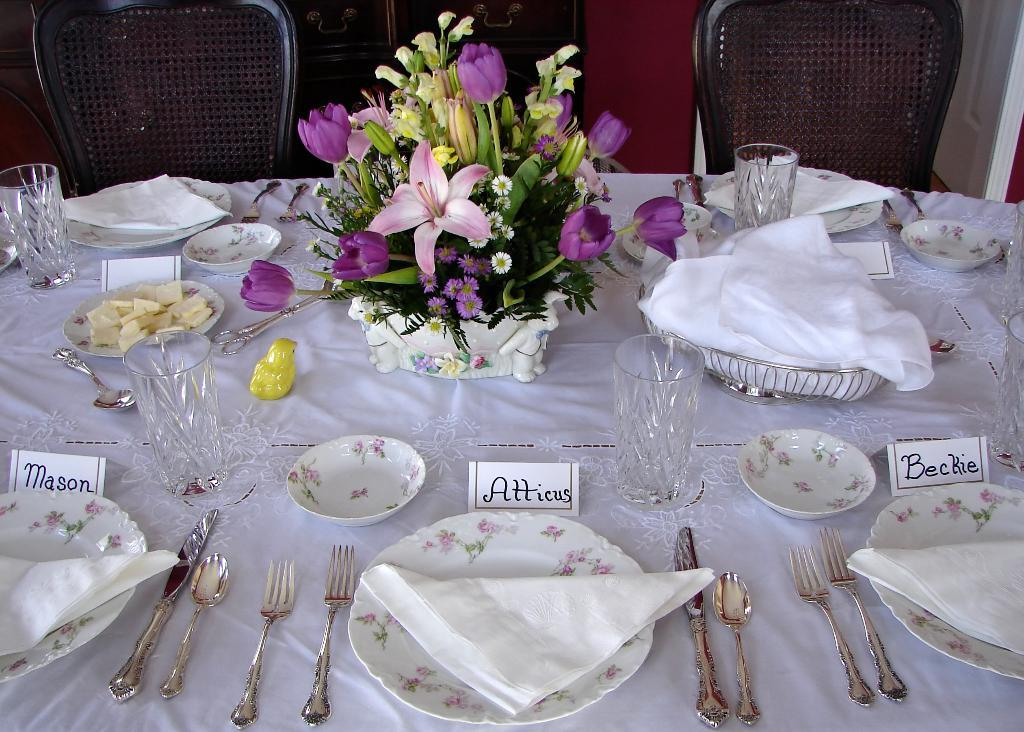What is covering the table in the image? There is a table with a white cloth in the image. What can be found on top of the table? There are plates and other objects on the table. How many chairs are beside the table? There are two chairs beside the table. What type of club is being used to stir the soup in the image? There is no club or soup present in the image. 